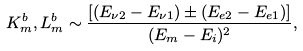Convert formula to latex. <formula><loc_0><loc_0><loc_500><loc_500>K ^ { b } _ { m } , L ^ { b } _ { m } \sim \frac { [ ( E _ { \nu 2 } - E _ { \nu 1 } ) \pm ( E _ { e 2 } - E _ { e 1 } ) ] } { ( E _ { m } - E _ { i } ) ^ { 2 } } ,</formula> 